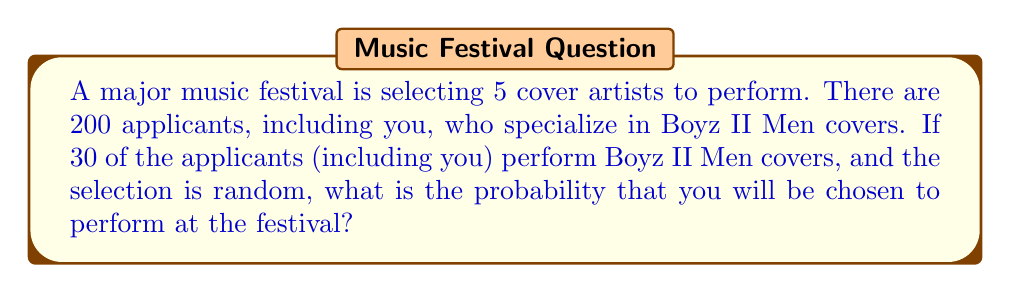Could you help me with this problem? Let's approach this step-by-step:

1) First, we need to calculate the probability of being selected in a single draw. This is the number of favorable outcomes divided by the total number of possible outcomes:

   $P(\text{being selected in one draw}) = \frac{1}{200}$

2) However, we're not just interested in one draw, but in being selected as one of the 5 performers. We can think of this as the probability of being selected in any of the 5 draws.

3) It's easier to calculate the probability of not being selected in any of the 5 draws, and then subtract this from 1 to get the probability of being selected.

4) The probability of not being selected in one draw is:

   $P(\text{not being selected in one draw}) = \frac{199}{200}$

5) For all 5 draws, assuming the number of applicants doesn't change significantly (which is a reasonable approximation given the large number of applicants), the probability of not being selected in any of the 5 draws is:

   $P(\text{not selected in 5 draws}) = (\frac{199}{200})^5$

6) Therefore, the probability of being selected in at least one of the 5 draws is:

   $P(\text{selected}) = 1 - (\frac{199}{200})^5$

7) Let's calculate this:

   $1 - (\frac{199}{200})^5 = 1 - 0.9753 = 0.0247$

8) Converting to a percentage:

   $0.0247 \times 100\% = 2.47\%$
Answer: 2.47% 